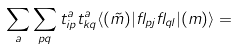Convert formula to latex. <formula><loc_0><loc_0><loc_500><loc_500>\sum _ { a } \sum _ { p q } t ^ { a } _ { i p } t ^ { a } _ { k q } \langle ( \tilde { m } ) | \gamma _ { p j } \gamma _ { q l } | ( m ) \rangle =</formula> 